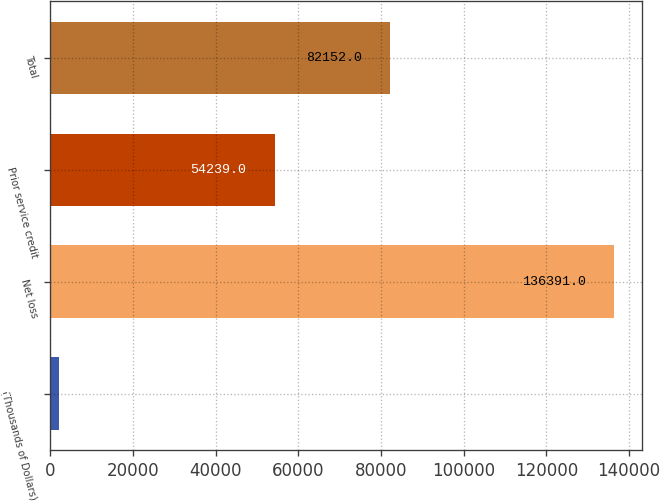<chart> <loc_0><loc_0><loc_500><loc_500><bar_chart><fcel>(Thousands of Dollars)<fcel>Net loss<fcel>Prior service credit<fcel>Total<nl><fcel>2016<fcel>136391<fcel>54239<fcel>82152<nl></chart> 